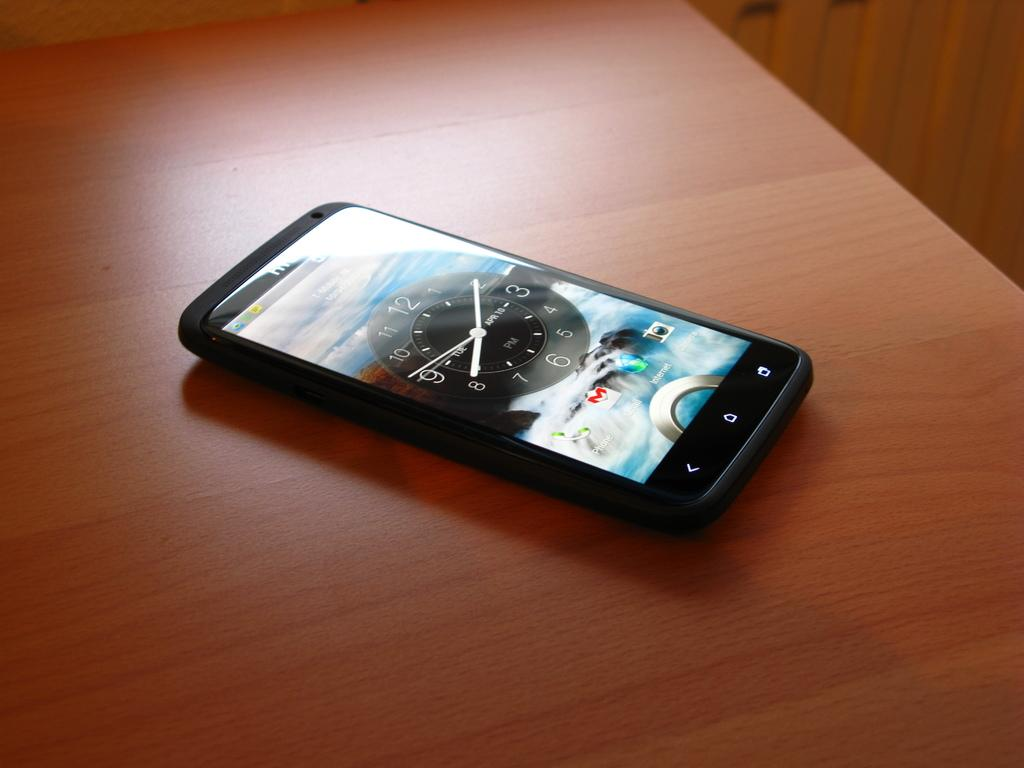<image>
Give a short and clear explanation of the subsequent image. A smart phone sits on the table and its lock screen reads 8:10. 